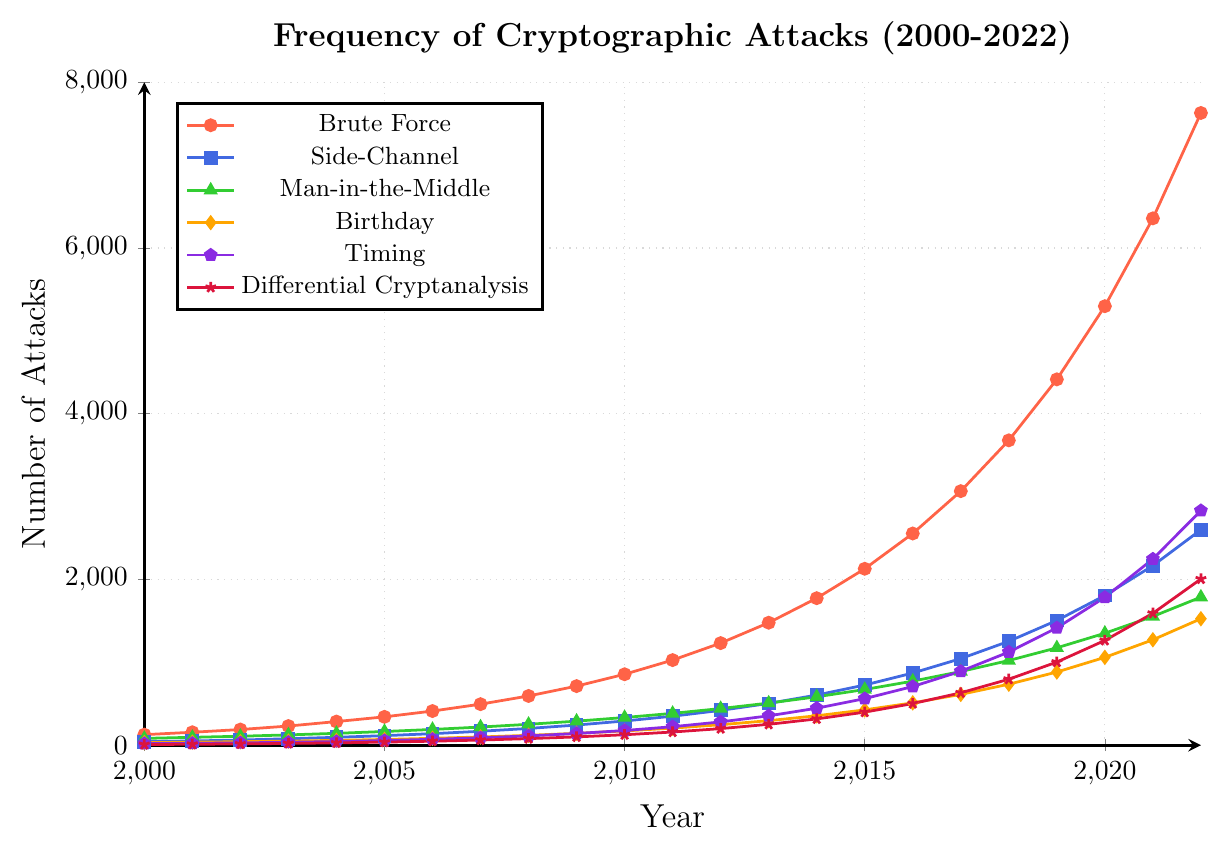What is the total number of Man-in-the-Middle attacks reported in 2010 and 2012 combined? First, find the number of Man-in-the-Middle attacks in 2010, which is 334, and in 2012, which is 442. Then, sum these numbers: 334 + 442 = 776.
Answer: 776 Which type of attack had the highest number of reports in 2022? Compare the numbers of each type of attack in 2022. Brute Force is the highest with 7630 reports.
Answer: Brute Force Between 2000 and 2022, which attack type showed the most consistent year-over-year growth? Visually inspect the lines on the chart. The line for Brute Force attacks shows consistent growth across the years.
Answer: Brute Force How does the frequency of Timing attacks in 2021 compare to those in 2018? Look at the data points for Timing attacks in 2021 (2247) and 2018 (1124). Compare the two numbers: 2247 is greater than 1124.
Answer: Greater What was the average number of Brute Force attacks reported from 2000 to 2005? Sum the Brute Force attacks from 2000 to 2005: 127 + 156 + 189 + 231 + 285 + 342 = 1330. Divide by the number of years, which is 6: 1330 / 6 ≈ 221.67.
Answer: 221.67 Which color represents Differential Cryptanalysis attacks? Look at the legend and match Differential Cryptanalysis to its color, which is represented by the color red.
Answer: Red Calculate the difference in the number of Side-Channel attacks reported between 2015 and 2020. Find the number of Side-Channel attacks in 2015 (726) and in 2020 (1806), then compute the difference: 1806 - 726 = 1080.
Answer: 1080 Which year saw the highest number of Birthday attacks reported? Observe the data points for Birthday attacks over the years. The highest value is in 2022 with 1526 attacks.
Answer: 2022 What is the sum of the most recent (2022) reports of Side-Channel, Man-in-the-Middle, and Timing attacks? Add the numbers for 2022 reports: Side-Channel (2600), Man-in-the-Middle (1787), and Timing (2831). So, 2600 + 1787 + 2831 = 7218.
Answer: 7218 In which year did Brute Force attacks first exceed 1000 reports? Look at the data points for Brute Force attacks and find the year when it first exceeds 1000 reports. The year is 2011 with 1027 reports.
Answer: 2011 